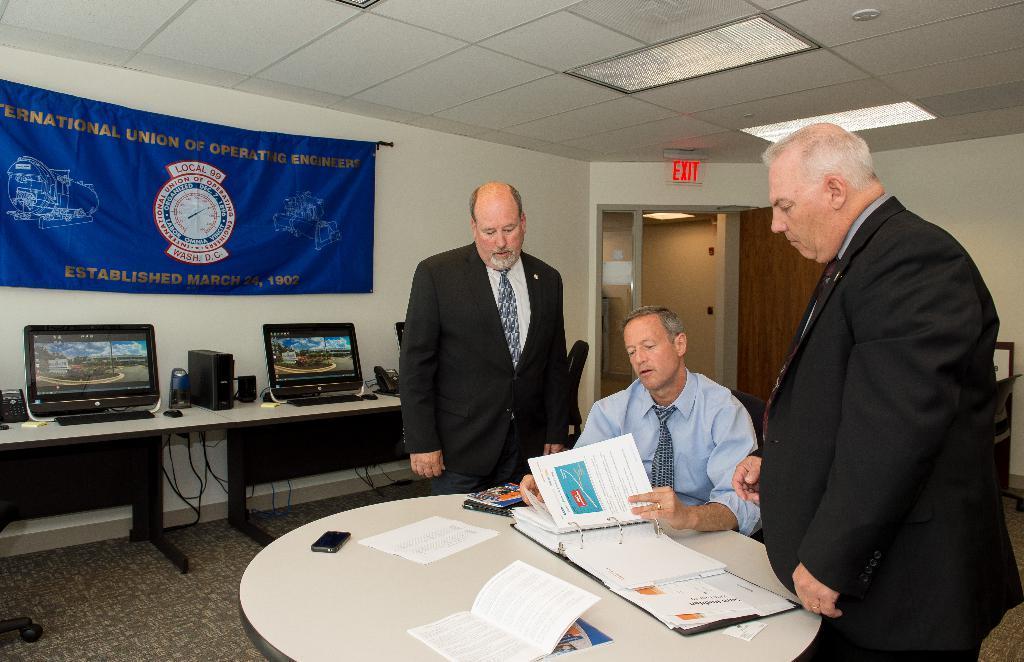In one or two sentences, can you explain what this image depicts? In this image we can see a man is sitting on a chair and holding papers in the hands of a book and other two men are standing. There is a book, papers, mobile and objects are on the table. In the background we can see a banner and board on the wall, monitors, keyboard, telephone and objects are on a table, door, lights on the ceiling and other objects. 